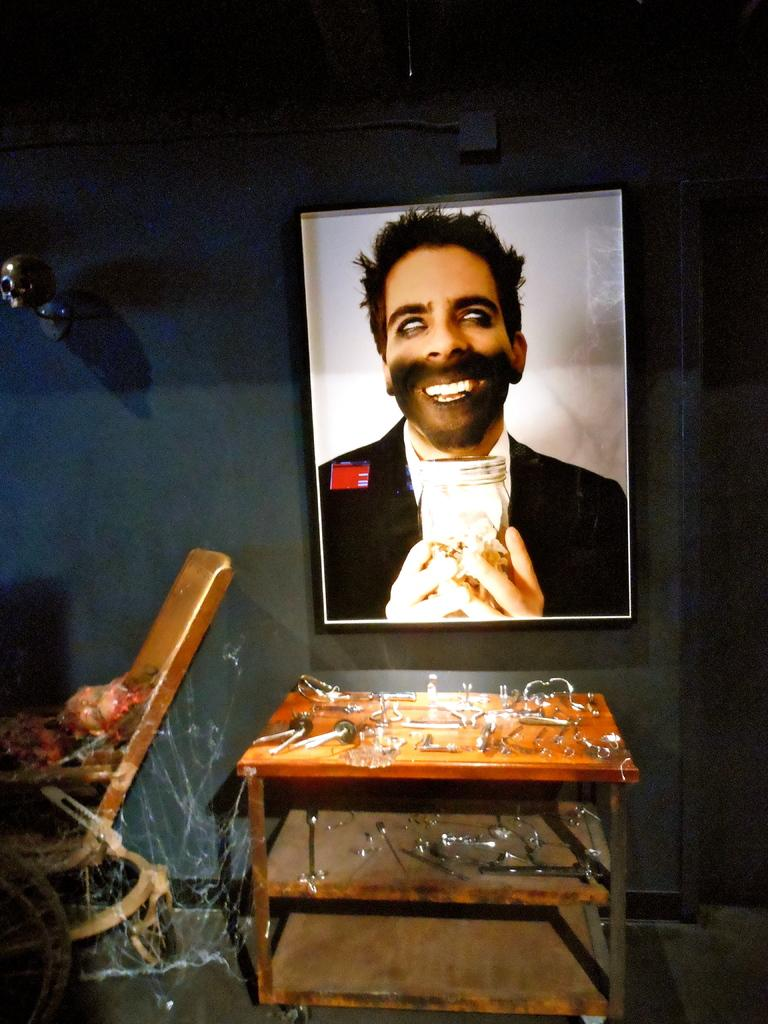What is hanging on the wall in the image? There is a frame on the wall and a skull on the wall. What can be found on the table in the image? There are objects on the table. Where is the chair located in the image? The chair is on the left side of the image. Is there a carriage visible in the image? No, there is no carriage present in the image. Can you see a ring on the chair in the image? No, there is no ring visible on the chair in the image. 